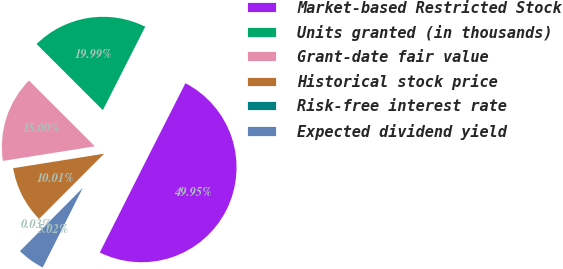Convert chart to OTSL. <chart><loc_0><loc_0><loc_500><loc_500><pie_chart><fcel>Market-based Restricted Stock<fcel>Units granted (in thousands)<fcel>Grant-date fair value<fcel>Historical stock price<fcel>Risk-free interest rate<fcel>Expected dividend yield<nl><fcel>49.95%<fcel>19.99%<fcel>15.0%<fcel>10.01%<fcel>0.03%<fcel>5.02%<nl></chart> 